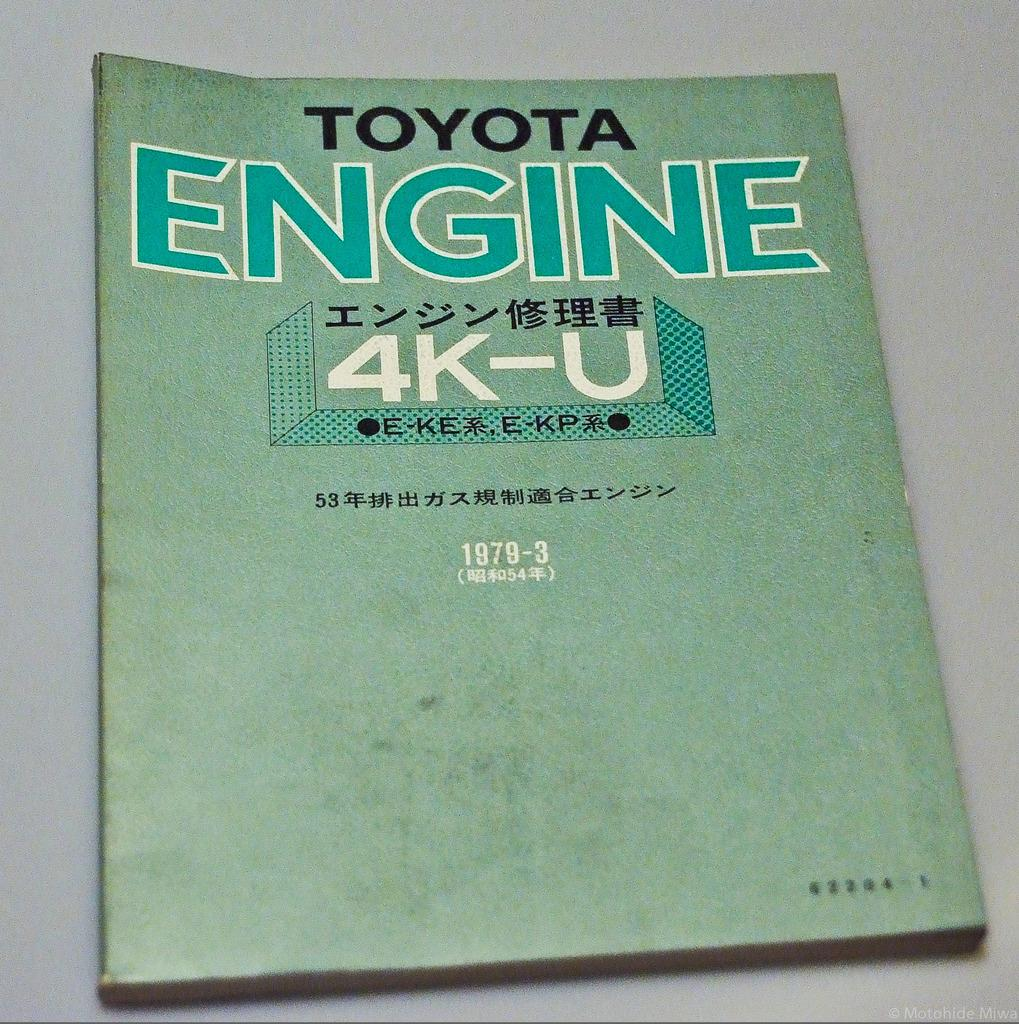<image>
Provide a brief description of the given image. An old engine manual for a Toyota printed in Asian. 